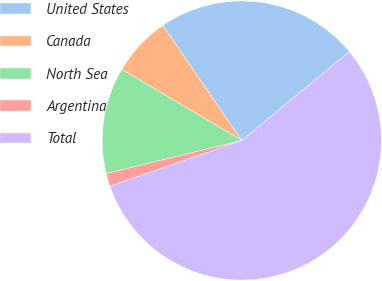Convert chart to OTSL. <chart><loc_0><loc_0><loc_500><loc_500><pie_chart><fcel>United States<fcel>Canada<fcel>North Sea<fcel>Argentina<fcel>Total<nl><fcel>23.59%<fcel>6.91%<fcel>12.33%<fcel>1.5%<fcel>55.67%<nl></chart> 